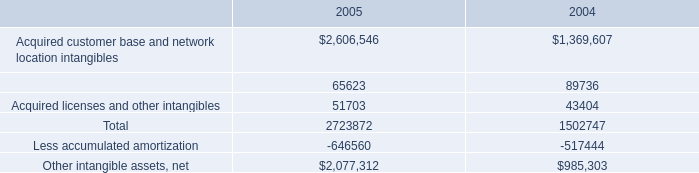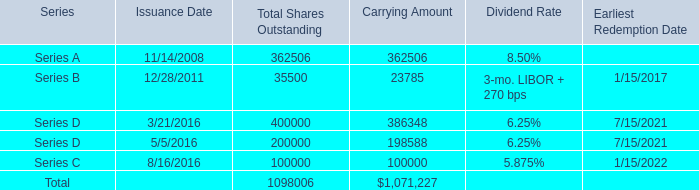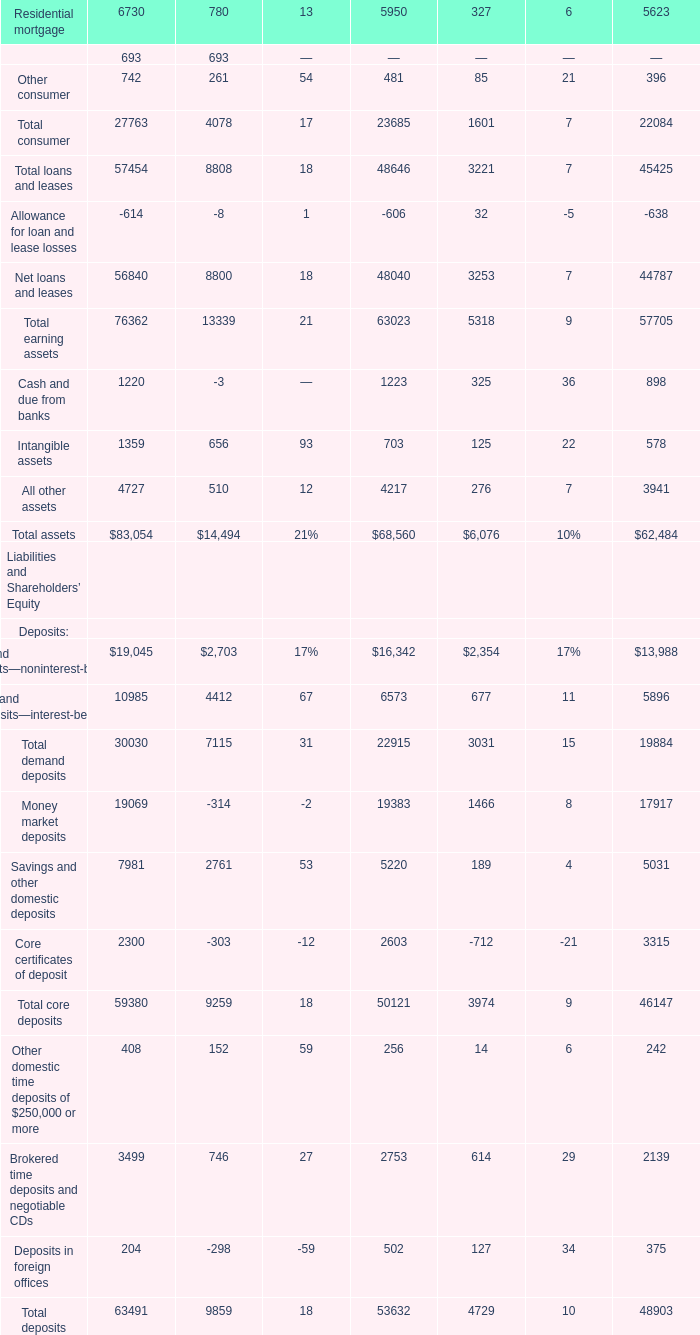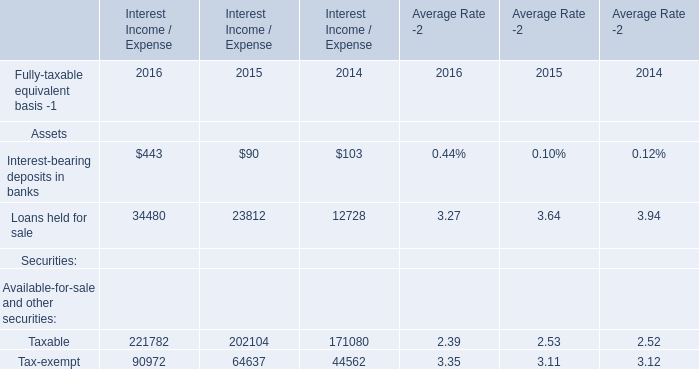Which year is Loans held for sale the most? 
Answer: 2016. 